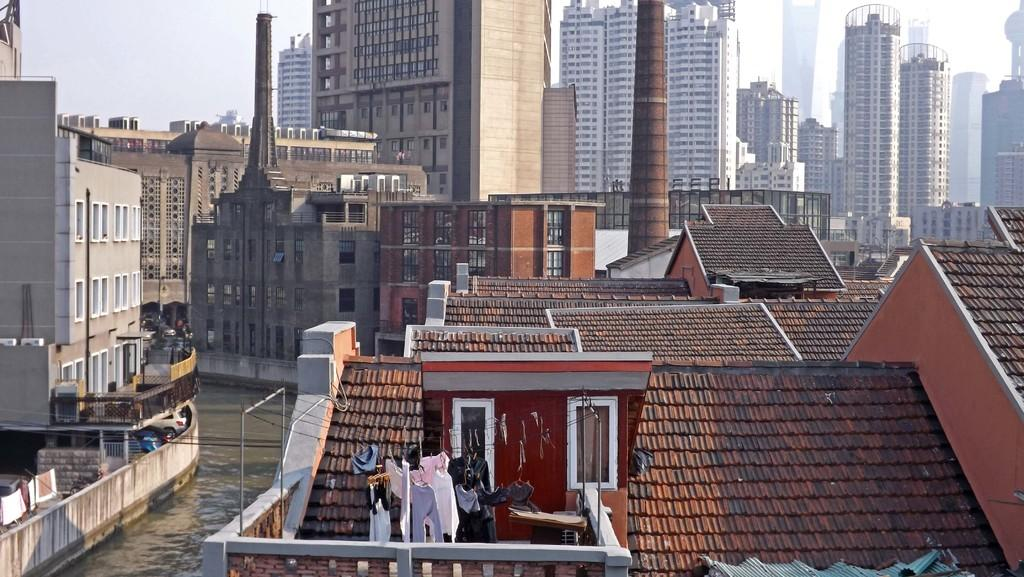What part of a building can be seen in the image? The roof of a building is visible in the image. What is hanging from the wires in the image? There are clothes hanged on wires in the image. What natural element is present in the image? There is water visible in the image. How many buildings can be seen in the image? There are other buildings in the image. What is visible in the background of the image? The sky is visible in the background of the image. What type of field can be seen in the image? There is no field present in the image; it features a roof, clothes on wires, water, other buildings, and the sky. 